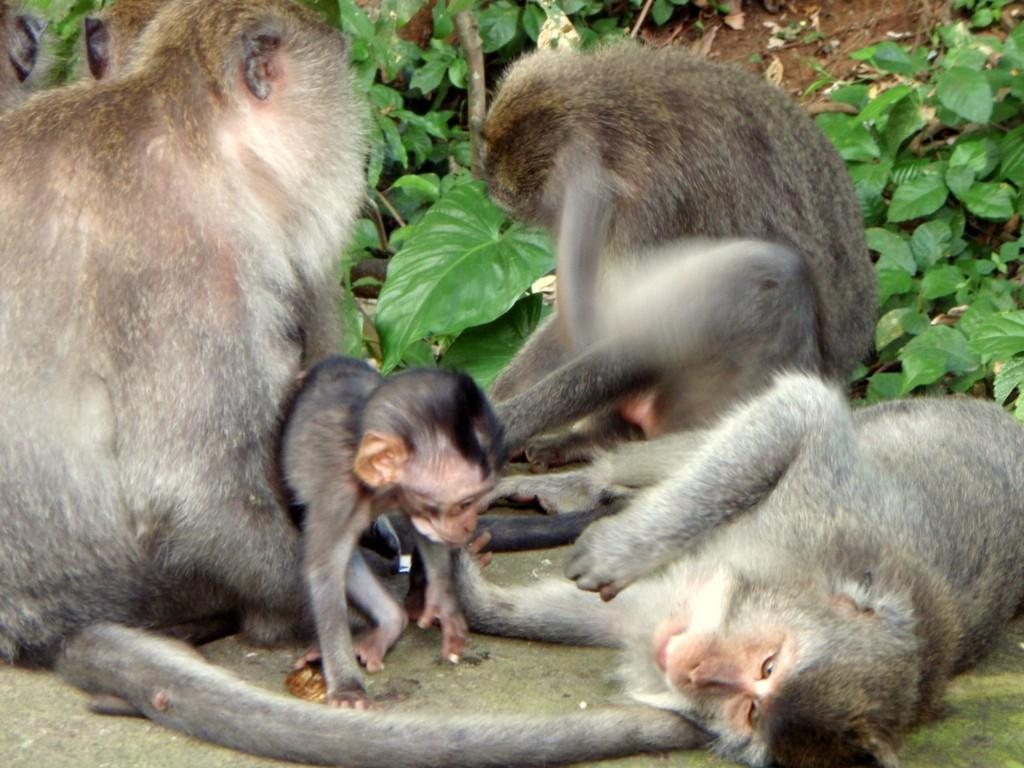What animals are present in the image? There are monkeys in the image. What can be seen in the background of the image? There are green leaves in the background of the image. What force is being applied to the monkeys in the image? There is no force being applied to the monkeys in the image; they are simply present. 